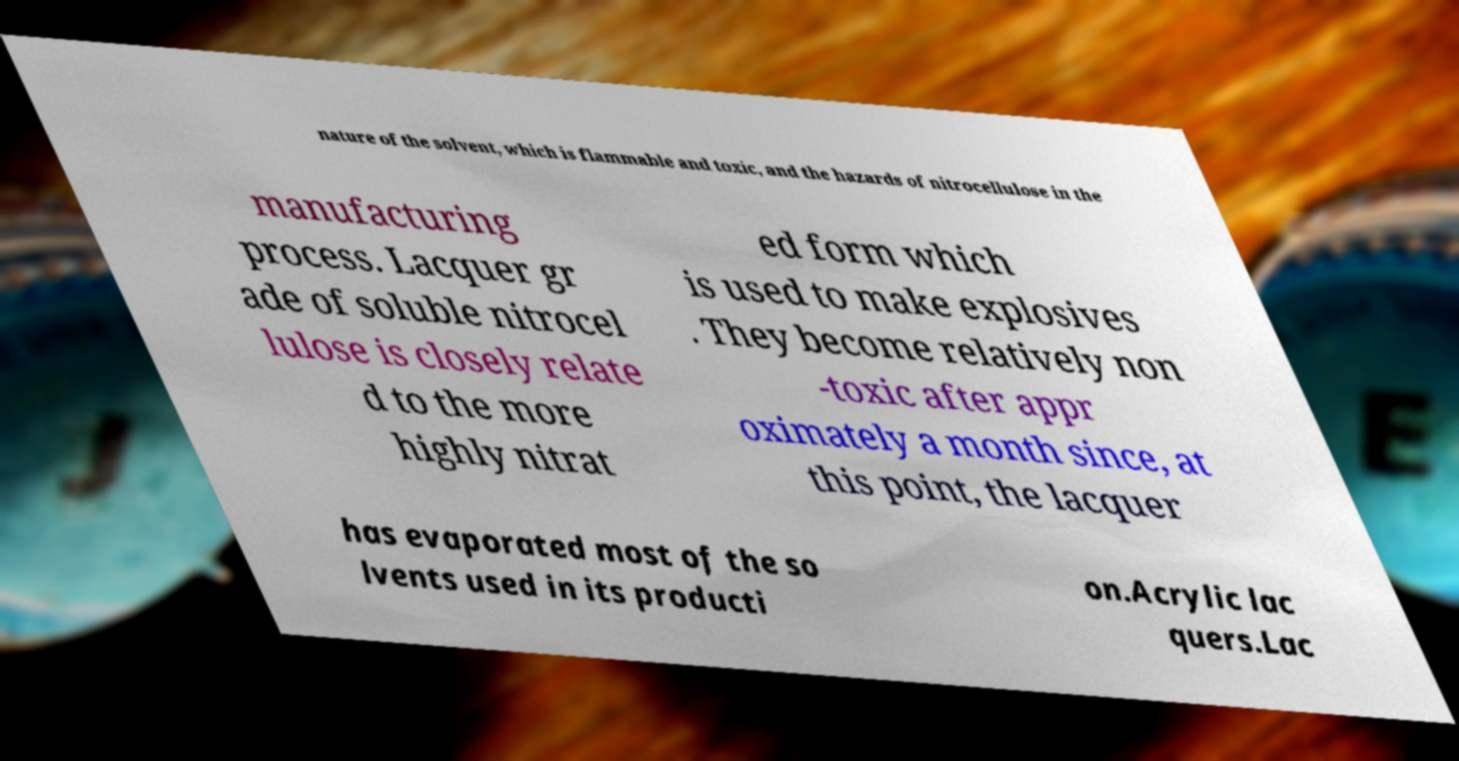Could you assist in decoding the text presented in this image and type it out clearly? nature of the solvent, which is flammable and toxic, and the hazards of nitrocellulose in the manufacturing process. Lacquer gr ade of soluble nitrocel lulose is closely relate d to the more highly nitrat ed form which is used to make explosives . They become relatively non -toxic after appr oximately a month since, at this point, the lacquer has evaporated most of the so lvents used in its producti on.Acrylic lac quers.Lac 